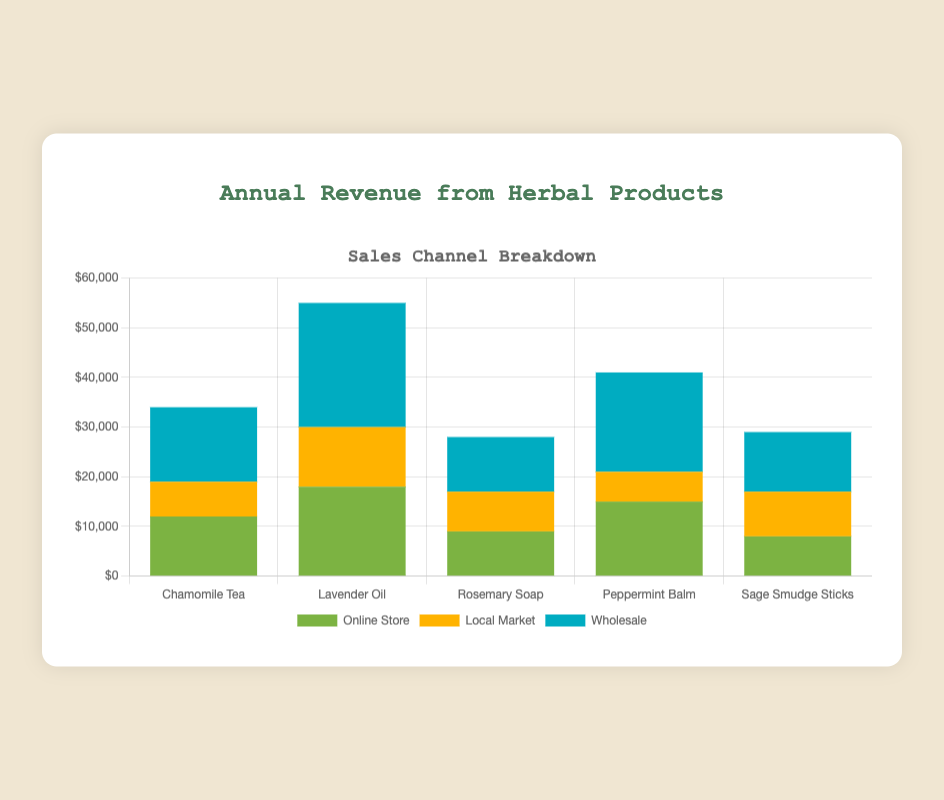What product has the highest total revenue? To find the product with the highest total revenue, sum the revenues from all sales channels for each product. The highest total is for Lavender Oil with (18000 + 12000 + 25000) = 55000.
Answer: Lavender Oil Which product has the lowest revenue in the Online Store? Review the data for the Online Store sales. The smallest value is 8000 for Sage Smudge Sticks.
Answer: Sage Smudge Sticks What is the total revenue from the Local Market channel across all products? Sum the Local Market revenues of all products: (7000 + 12000 + 8000 + 6000 + 9000) = 42000.
Answer: 42000 How much more revenue does Lavender Oil generate from Wholesale compared to Rosemary Soap? Compare the Wholesale revenues for these products: Lavender Oil (25000) and Rosemary Soap (11000). The difference is 25000 - 11000 = 14000.
Answer: 14000 Which sales channel contributes the most to Peppermint Balm's revenue? Look at the revenue breakdown for Peppermint Balm and identify the highest amount: Wholesale with 20000.
Answer: Wholesale Which product has the highest revenue from the Local Market? Review the Local Market revenue figures and identify the highest value, which is Lavender Oil with 12000.
Answer: Lavender Oil Among all products, which one has the smallest difference in revenue between the highest and lowest performing channels? Calculate the differences for each product: 
- Chamomile Tea: max(15000) - min(7000) = 8000
- Lavender Oil: max(25000) - min(12000) = 13000
- Rosemary Soap: max(11000) - min(8000) = 3000
- Peppermint Balm: max(20000) - min(6000) = 14000
- Sage Smudge Sticks: max(12000) - min(8000) = 4000
The smallest difference is for Rosemary Soap with 3000.
Answer: Rosemary Soap What is the combined revenue from all channels for Sage Smudge Sticks? Sum the revenues of Sage Smudge Sticks from all channels: (8000 + 9000 + 12000) = 29000.
Answer: 29000 What is the percentage contribution of the Online Store to the total revenue of Chamomile Tea? Calculate the percentage contribution: (12000 / (12000 + 7000 + 15000)) * 100 = (12000 / 34000) * 100 ≈ 35.29%.
Answer: 35.29% What is the average revenue per product from the Wholesale channel? Sum the revenues from the Wholesale channel across all products and divide by the number of products: (15000 + 25000 + 11000 + 20000 + 12000) / 5 = 83000 / 5 = 16600.
Answer: 16600 